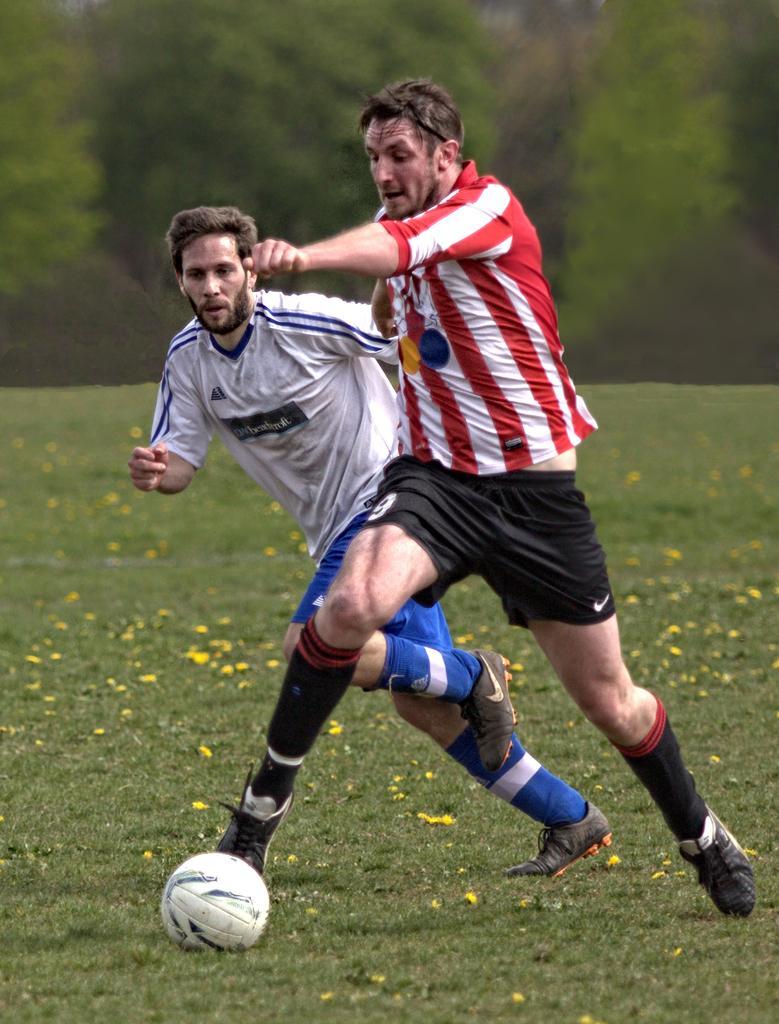Could you give a brief overview of what you see in this image? This is a picture taken in the outdoor, there are two men who are playing on the ground the man in red and white straps t shirt was kicking a ball. The ball is in white color. Background of this people is a tree. 